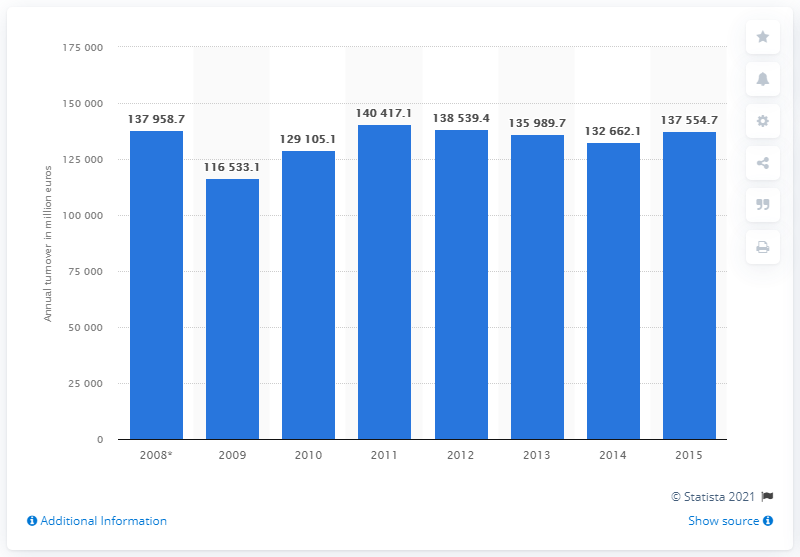Highlight a few significant elements in this photo. In 2015, the turnover of the wholesale and retail trade industry was 137,554.7 million. 